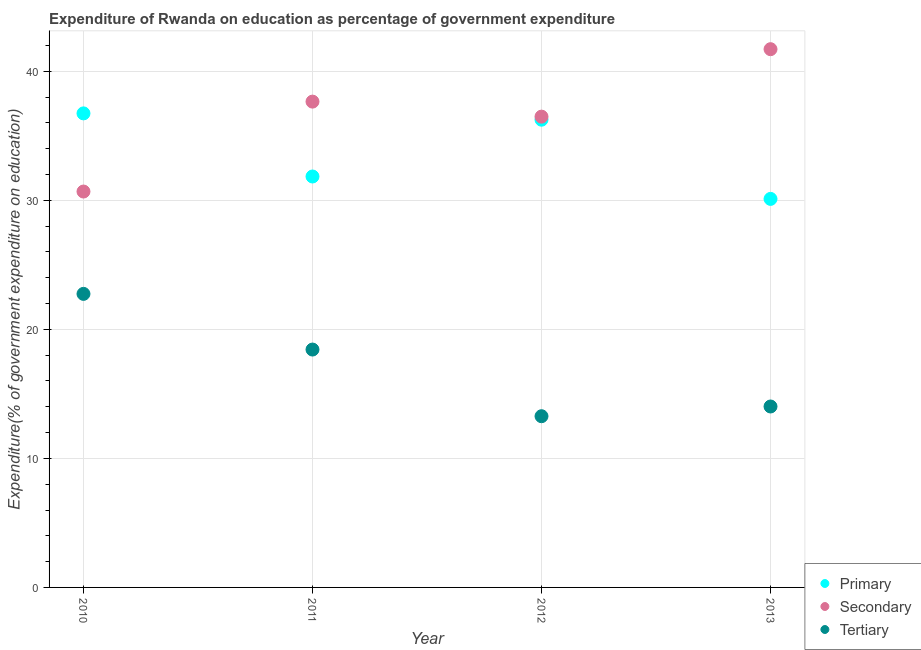Is the number of dotlines equal to the number of legend labels?
Your response must be concise. Yes. What is the expenditure on secondary education in 2012?
Provide a succinct answer. 36.49. Across all years, what is the maximum expenditure on primary education?
Ensure brevity in your answer.  36.74. Across all years, what is the minimum expenditure on secondary education?
Offer a terse response. 30.68. In which year was the expenditure on tertiary education minimum?
Offer a terse response. 2012. What is the total expenditure on secondary education in the graph?
Offer a terse response. 146.53. What is the difference between the expenditure on primary education in 2010 and that in 2013?
Keep it short and to the point. 6.63. What is the difference between the expenditure on tertiary education in 2011 and the expenditure on primary education in 2012?
Provide a short and direct response. -17.81. What is the average expenditure on tertiary education per year?
Provide a succinct answer. 17.12. In the year 2012, what is the difference between the expenditure on secondary education and expenditure on primary education?
Your answer should be very brief. 0.24. What is the ratio of the expenditure on tertiary education in 2010 to that in 2011?
Offer a very short reply. 1.23. Is the expenditure on secondary education in 2011 less than that in 2013?
Your answer should be compact. Yes. What is the difference between the highest and the second highest expenditure on secondary education?
Provide a succinct answer. 4.06. What is the difference between the highest and the lowest expenditure on primary education?
Make the answer very short. 6.63. In how many years, is the expenditure on tertiary education greater than the average expenditure on tertiary education taken over all years?
Keep it short and to the point. 2. Is the sum of the expenditure on secondary education in 2010 and 2013 greater than the maximum expenditure on primary education across all years?
Provide a short and direct response. Yes. Does the expenditure on tertiary education monotonically increase over the years?
Offer a very short reply. No. Is the expenditure on tertiary education strictly less than the expenditure on secondary education over the years?
Keep it short and to the point. Yes. How many years are there in the graph?
Keep it short and to the point. 4. Are the values on the major ticks of Y-axis written in scientific E-notation?
Your answer should be compact. No. Does the graph contain grids?
Offer a terse response. Yes. Where does the legend appear in the graph?
Offer a terse response. Bottom right. What is the title of the graph?
Give a very brief answer. Expenditure of Rwanda on education as percentage of government expenditure. What is the label or title of the X-axis?
Make the answer very short. Year. What is the label or title of the Y-axis?
Provide a succinct answer. Expenditure(% of government expenditure on education). What is the Expenditure(% of government expenditure on education) in Primary in 2010?
Provide a short and direct response. 36.74. What is the Expenditure(% of government expenditure on education) in Secondary in 2010?
Offer a very short reply. 30.68. What is the Expenditure(% of government expenditure on education) in Tertiary in 2010?
Your answer should be compact. 22.75. What is the Expenditure(% of government expenditure on education) in Primary in 2011?
Make the answer very short. 31.85. What is the Expenditure(% of government expenditure on education) in Secondary in 2011?
Your response must be concise. 37.65. What is the Expenditure(% of government expenditure on education) in Tertiary in 2011?
Your answer should be compact. 18.43. What is the Expenditure(% of government expenditure on education) in Primary in 2012?
Your answer should be very brief. 36.25. What is the Expenditure(% of government expenditure on education) of Secondary in 2012?
Your answer should be compact. 36.49. What is the Expenditure(% of government expenditure on education) of Tertiary in 2012?
Your response must be concise. 13.27. What is the Expenditure(% of government expenditure on education) in Primary in 2013?
Offer a very short reply. 30.11. What is the Expenditure(% of government expenditure on education) of Secondary in 2013?
Your answer should be very brief. 41.71. What is the Expenditure(% of government expenditure on education) in Tertiary in 2013?
Keep it short and to the point. 14.02. Across all years, what is the maximum Expenditure(% of government expenditure on education) of Primary?
Make the answer very short. 36.74. Across all years, what is the maximum Expenditure(% of government expenditure on education) in Secondary?
Give a very brief answer. 41.71. Across all years, what is the maximum Expenditure(% of government expenditure on education) in Tertiary?
Offer a very short reply. 22.75. Across all years, what is the minimum Expenditure(% of government expenditure on education) in Primary?
Your answer should be compact. 30.11. Across all years, what is the minimum Expenditure(% of government expenditure on education) of Secondary?
Your response must be concise. 30.68. Across all years, what is the minimum Expenditure(% of government expenditure on education) in Tertiary?
Your answer should be very brief. 13.27. What is the total Expenditure(% of government expenditure on education) of Primary in the graph?
Offer a very short reply. 134.94. What is the total Expenditure(% of government expenditure on education) in Secondary in the graph?
Provide a succinct answer. 146.53. What is the total Expenditure(% of government expenditure on education) in Tertiary in the graph?
Make the answer very short. 68.48. What is the difference between the Expenditure(% of government expenditure on education) of Primary in 2010 and that in 2011?
Make the answer very short. 4.89. What is the difference between the Expenditure(% of government expenditure on education) in Secondary in 2010 and that in 2011?
Your answer should be compact. -6.97. What is the difference between the Expenditure(% of government expenditure on education) in Tertiary in 2010 and that in 2011?
Your answer should be very brief. 4.31. What is the difference between the Expenditure(% of government expenditure on education) of Primary in 2010 and that in 2012?
Your answer should be very brief. 0.49. What is the difference between the Expenditure(% of government expenditure on education) in Secondary in 2010 and that in 2012?
Your answer should be very brief. -5.8. What is the difference between the Expenditure(% of government expenditure on education) of Tertiary in 2010 and that in 2012?
Give a very brief answer. 9.48. What is the difference between the Expenditure(% of government expenditure on education) of Primary in 2010 and that in 2013?
Ensure brevity in your answer.  6.63. What is the difference between the Expenditure(% of government expenditure on education) in Secondary in 2010 and that in 2013?
Your response must be concise. -11.03. What is the difference between the Expenditure(% of government expenditure on education) in Tertiary in 2010 and that in 2013?
Give a very brief answer. 8.73. What is the difference between the Expenditure(% of government expenditure on education) in Primary in 2011 and that in 2012?
Your answer should be very brief. -4.4. What is the difference between the Expenditure(% of government expenditure on education) in Secondary in 2011 and that in 2012?
Your response must be concise. 1.16. What is the difference between the Expenditure(% of government expenditure on education) in Tertiary in 2011 and that in 2012?
Offer a very short reply. 5.17. What is the difference between the Expenditure(% of government expenditure on education) of Primary in 2011 and that in 2013?
Offer a terse response. 1.74. What is the difference between the Expenditure(% of government expenditure on education) in Secondary in 2011 and that in 2013?
Your response must be concise. -4.06. What is the difference between the Expenditure(% of government expenditure on education) of Tertiary in 2011 and that in 2013?
Your response must be concise. 4.41. What is the difference between the Expenditure(% of government expenditure on education) in Primary in 2012 and that in 2013?
Provide a succinct answer. 6.14. What is the difference between the Expenditure(% of government expenditure on education) in Secondary in 2012 and that in 2013?
Provide a succinct answer. -5.23. What is the difference between the Expenditure(% of government expenditure on education) of Tertiary in 2012 and that in 2013?
Your response must be concise. -0.75. What is the difference between the Expenditure(% of government expenditure on education) in Primary in 2010 and the Expenditure(% of government expenditure on education) in Secondary in 2011?
Your answer should be very brief. -0.91. What is the difference between the Expenditure(% of government expenditure on education) of Primary in 2010 and the Expenditure(% of government expenditure on education) of Tertiary in 2011?
Keep it short and to the point. 18.3. What is the difference between the Expenditure(% of government expenditure on education) of Secondary in 2010 and the Expenditure(% of government expenditure on education) of Tertiary in 2011?
Ensure brevity in your answer.  12.25. What is the difference between the Expenditure(% of government expenditure on education) of Primary in 2010 and the Expenditure(% of government expenditure on education) of Secondary in 2012?
Your answer should be compact. 0.25. What is the difference between the Expenditure(% of government expenditure on education) in Primary in 2010 and the Expenditure(% of government expenditure on education) in Tertiary in 2012?
Provide a short and direct response. 23.47. What is the difference between the Expenditure(% of government expenditure on education) of Secondary in 2010 and the Expenditure(% of government expenditure on education) of Tertiary in 2012?
Provide a succinct answer. 17.41. What is the difference between the Expenditure(% of government expenditure on education) of Primary in 2010 and the Expenditure(% of government expenditure on education) of Secondary in 2013?
Keep it short and to the point. -4.98. What is the difference between the Expenditure(% of government expenditure on education) in Primary in 2010 and the Expenditure(% of government expenditure on education) in Tertiary in 2013?
Offer a terse response. 22.72. What is the difference between the Expenditure(% of government expenditure on education) of Secondary in 2010 and the Expenditure(% of government expenditure on education) of Tertiary in 2013?
Your answer should be very brief. 16.66. What is the difference between the Expenditure(% of government expenditure on education) of Primary in 2011 and the Expenditure(% of government expenditure on education) of Secondary in 2012?
Your answer should be very brief. -4.64. What is the difference between the Expenditure(% of government expenditure on education) in Primary in 2011 and the Expenditure(% of government expenditure on education) in Tertiary in 2012?
Give a very brief answer. 18.58. What is the difference between the Expenditure(% of government expenditure on education) of Secondary in 2011 and the Expenditure(% of government expenditure on education) of Tertiary in 2012?
Offer a terse response. 24.38. What is the difference between the Expenditure(% of government expenditure on education) in Primary in 2011 and the Expenditure(% of government expenditure on education) in Secondary in 2013?
Your answer should be compact. -9.87. What is the difference between the Expenditure(% of government expenditure on education) of Primary in 2011 and the Expenditure(% of government expenditure on education) of Tertiary in 2013?
Offer a terse response. 17.82. What is the difference between the Expenditure(% of government expenditure on education) in Secondary in 2011 and the Expenditure(% of government expenditure on education) in Tertiary in 2013?
Your answer should be compact. 23.63. What is the difference between the Expenditure(% of government expenditure on education) in Primary in 2012 and the Expenditure(% of government expenditure on education) in Secondary in 2013?
Your response must be concise. -5.46. What is the difference between the Expenditure(% of government expenditure on education) of Primary in 2012 and the Expenditure(% of government expenditure on education) of Tertiary in 2013?
Offer a terse response. 22.23. What is the difference between the Expenditure(% of government expenditure on education) of Secondary in 2012 and the Expenditure(% of government expenditure on education) of Tertiary in 2013?
Your answer should be compact. 22.46. What is the average Expenditure(% of government expenditure on education) of Primary per year?
Give a very brief answer. 33.74. What is the average Expenditure(% of government expenditure on education) in Secondary per year?
Keep it short and to the point. 36.63. What is the average Expenditure(% of government expenditure on education) of Tertiary per year?
Keep it short and to the point. 17.12. In the year 2010, what is the difference between the Expenditure(% of government expenditure on education) in Primary and Expenditure(% of government expenditure on education) in Secondary?
Keep it short and to the point. 6.06. In the year 2010, what is the difference between the Expenditure(% of government expenditure on education) of Primary and Expenditure(% of government expenditure on education) of Tertiary?
Provide a succinct answer. 13.99. In the year 2010, what is the difference between the Expenditure(% of government expenditure on education) of Secondary and Expenditure(% of government expenditure on education) of Tertiary?
Provide a short and direct response. 7.93. In the year 2011, what is the difference between the Expenditure(% of government expenditure on education) of Primary and Expenditure(% of government expenditure on education) of Secondary?
Your answer should be compact. -5.8. In the year 2011, what is the difference between the Expenditure(% of government expenditure on education) in Primary and Expenditure(% of government expenditure on education) in Tertiary?
Give a very brief answer. 13.41. In the year 2011, what is the difference between the Expenditure(% of government expenditure on education) in Secondary and Expenditure(% of government expenditure on education) in Tertiary?
Offer a very short reply. 19.21. In the year 2012, what is the difference between the Expenditure(% of government expenditure on education) of Primary and Expenditure(% of government expenditure on education) of Secondary?
Offer a terse response. -0.24. In the year 2012, what is the difference between the Expenditure(% of government expenditure on education) of Primary and Expenditure(% of government expenditure on education) of Tertiary?
Keep it short and to the point. 22.98. In the year 2012, what is the difference between the Expenditure(% of government expenditure on education) in Secondary and Expenditure(% of government expenditure on education) in Tertiary?
Provide a short and direct response. 23.22. In the year 2013, what is the difference between the Expenditure(% of government expenditure on education) in Primary and Expenditure(% of government expenditure on education) in Secondary?
Your answer should be compact. -11.6. In the year 2013, what is the difference between the Expenditure(% of government expenditure on education) of Primary and Expenditure(% of government expenditure on education) of Tertiary?
Keep it short and to the point. 16.09. In the year 2013, what is the difference between the Expenditure(% of government expenditure on education) in Secondary and Expenditure(% of government expenditure on education) in Tertiary?
Offer a terse response. 27.69. What is the ratio of the Expenditure(% of government expenditure on education) in Primary in 2010 to that in 2011?
Offer a very short reply. 1.15. What is the ratio of the Expenditure(% of government expenditure on education) of Secondary in 2010 to that in 2011?
Provide a short and direct response. 0.81. What is the ratio of the Expenditure(% of government expenditure on education) of Tertiary in 2010 to that in 2011?
Provide a succinct answer. 1.23. What is the ratio of the Expenditure(% of government expenditure on education) of Primary in 2010 to that in 2012?
Your answer should be compact. 1.01. What is the ratio of the Expenditure(% of government expenditure on education) in Secondary in 2010 to that in 2012?
Provide a short and direct response. 0.84. What is the ratio of the Expenditure(% of government expenditure on education) in Tertiary in 2010 to that in 2012?
Offer a terse response. 1.71. What is the ratio of the Expenditure(% of government expenditure on education) in Primary in 2010 to that in 2013?
Offer a terse response. 1.22. What is the ratio of the Expenditure(% of government expenditure on education) in Secondary in 2010 to that in 2013?
Your answer should be very brief. 0.74. What is the ratio of the Expenditure(% of government expenditure on education) in Tertiary in 2010 to that in 2013?
Give a very brief answer. 1.62. What is the ratio of the Expenditure(% of government expenditure on education) in Primary in 2011 to that in 2012?
Offer a very short reply. 0.88. What is the ratio of the Expenditure(% of government expenditure on education) of Secondary in 2011 to that in 2012?
Your response must be concise. 1.03. What is the ratio of the Expenditure(% of government expenditure on education) in Tertiary in 2011 to that in 2012?
Your answer should be very brief. 1.39. What is the ratio of the Expenditure(% of government expenditure on education) of Primary in 2011 to that in 2013?
Ensure brevity in your answer.  1.06. What is the ratio of the Expenditure(% of government expenditure on education) in Secondary in 2011 to that in 2013?
Your answer should be very brief. 0.9. What is the ratio of the Expenditure(% of government expenditure on education) of Tertiary in 2011 to that in 2013?
Provide a short and direct response. 1.31. What is the ratio of the Expenditure(% of government expenditure on education) of Primary in 2012 to that in 2013?
Offer a terse response. 1.2. What is the ratio of the Expenditure(% of government expenditure on education) in Secondary in 2012 to that in 2013?
Offer a very short reply. 0.87. What is the ratio of the Expenditure(% of government expenditure on education) in Tertiary in 2012 to that in 2013?
Provide a short and direct response. 0.95. What is the difference between the highest and the second highest Expenditure(% of government expenditure on education) of Primary?
Your answer should be compact. 0.49. What is the difference between the highest and the second highest Expenditure(% of government expenditure on education) in Secondary?
Provide a short and direct response. 4.06. What is the difference between the highest and the second highest Expenditure(% of government expenditure on education) in Tertiary?
Your answer should be compact. 4.31. What is the difference between the highest and the lowest Expenditure(% of government expenditure on education) of Primary?
Your answer should be compact. 6.63. What is the difference between the highest and the lowest Expenditure(% of government expenditure on education) in Secondary?
Offer a very short reply. 11.03. What is the difference between the highest and the lowest Expenditure(% of government expenditure on education) of Tertiary?
Your answer should be compact. 9.48. 